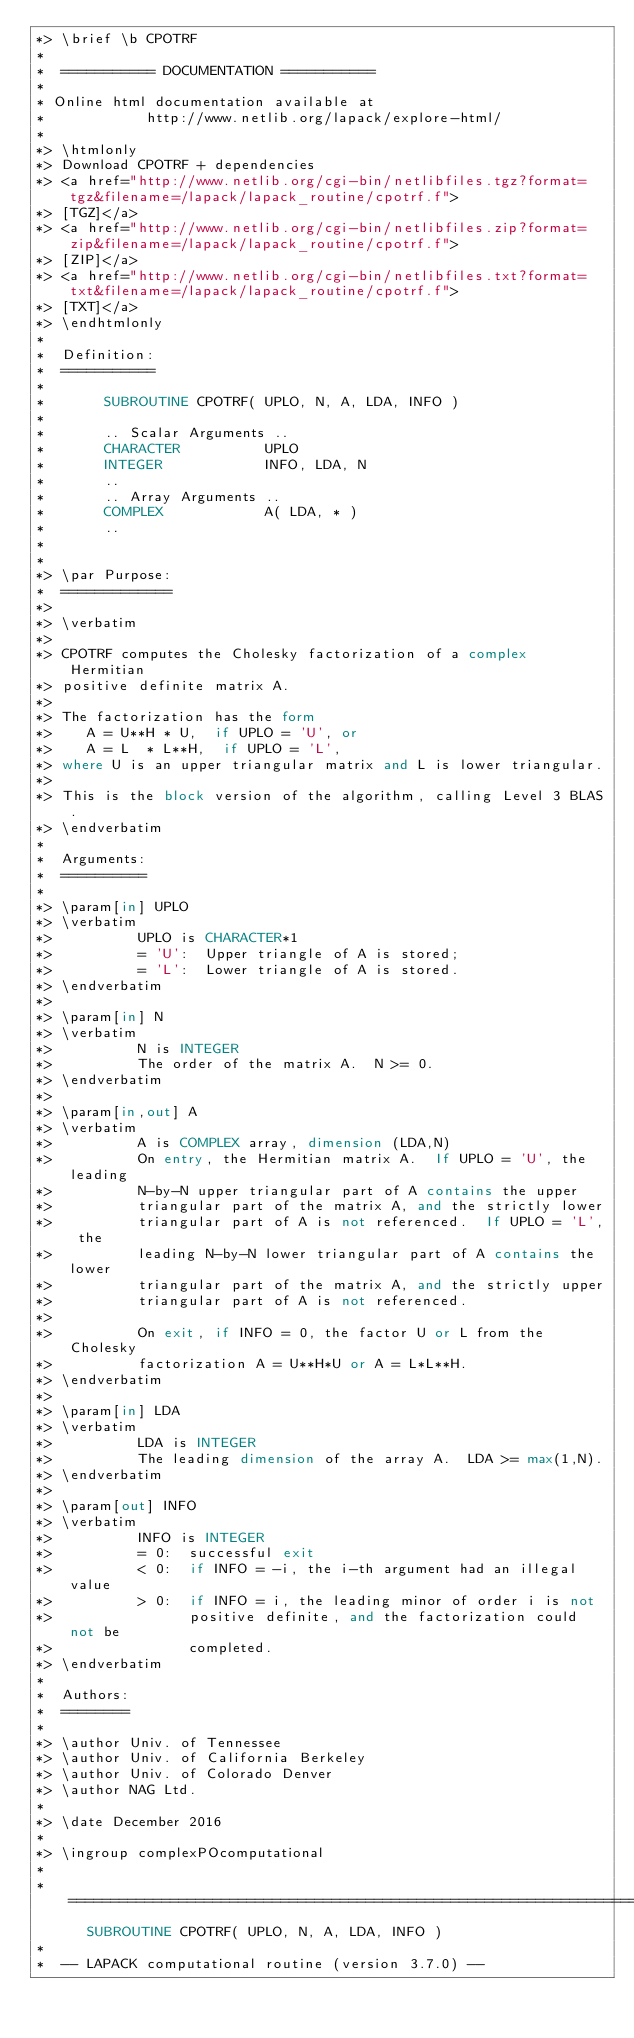<code> <loc_0><loc_0><loc_500><loc_500><_FORTRAN_>*> \brief \b CPOTRF
*
*  =========== DOCUMENTATION ===========
*
* Online html documentation available at
*            http://www.netlib.org/lapack/explore-html/
*
*> \htmlonly
*> Download CPOTRF + dependencies
*> <a href="http://www.netlib.org/cgi-bin/netlibfiles.tgz?format=tgz&filename=/lapack/lapack_routine/cpotrf.f">
*> [TGZ]</a>
*> <a href="http://www.netlib.org/cgi-bin/netlibfiles.zip?format=zip&filename=/lapack/lapack_routine/cpotrf.f">
*> [ZIP]</a>
*> <a href="http://www.netlib.org/cgi-bin/netlibfiles.txt?format=txt&filename=/lapack/lapack_routine/cpotrf.f">
*> [TXT]</a>
*> \endhtmlonly
*
*  Definition:
*  ===========
*
*       SUBROUTINE CPOTRF( UPLO, N, A, LDA, INFO )
*
*       .. Scalar Arguments ..
*       CHARACTER          UPLO
*       INTEGER            INFO, LDA, N
*       ..
*       .. Array Arguments ..
*       COMPLEX            A( LDA, * )
*       ..
*
*
*> \par Purpose:
*  =============
*>
*> \verbatim
*>
*> CPOTRF computes the Cholesky factorization of a complex Hermitian
*> positive definite matrix A.
*>
*> The factorization has the form
*>    A = U**H * U,  if UPLO = 'U', or
*>    A = L  * L**H,  if UPLO = 'L',
*> where U is an upper triangular matrix and L is lower triangular.
*>
*> This is the block version of the algorithm, calling Level 3 BLAS.
*> \endverbatim
*
*  Arguments:
*  ==========
*
*> \param[in] UPLO
*> \verbatim
*>          UPLO is CHARACTER*1
*>          = 'U':  Upper triangle of A is stored;
*>          = 'L':  Lower triangle of A is stored.
*> \endverbatim
*>
*> \param[in] N
*> \verbatim
*>          N is INTEGER
*>          The order of the matrix A.  N >= 0.
*> \endverbatim
*>
*> \param[in,out] A
*> \verbatim
*>          A is COMPLEX array, dimension (LDA,N)
*>          On entry, the Hermitian matrix A.  If UPLO = 'U', the leading
*>          N-by-N upper triangular part of A contains the upper
*>          triangular part of the matrix A, and the strictly lower
*>          triangular part of A is not referenced.  If UPLO = 'L', the
*>          leading N-by-N lower triangular part of A contains the lower
*>          triangular part of the matrix A, and the strictly upper
*>          triangular part of A is not referenced.
*>
*>          On exit, if INFO = 0, the factor U or L from the Cholesky
*>          factorization A = U**H*U or A = L*L**H.
*> \endverbatim
*>
*> \param[in] LDA
*> \verbatim
*>          LDA is INTEGER
*>          The leading dimension of the array A.  LDA >= max(1,N).
*> \endverbatim
*>
*> \param[out] INFO
*> \verbatim
*>          INFO is INTEGER
*>          = 0:  successful exit
*>          < 0:  if INFO = -i, the i-th argument had an illegal value
*>          > 0:  if INFO = i, the leading minor of order i is not
*>                positive definite, and the factorization could not be
*>                completed.
*> \endverbatim
*
*  Authors:
*  ========
*
*> \author Univ. of Tennessee
*> \author Univ. of California Berkeley
*> \author Univ. of Colorado Denver
*> \author NAG Ltd.
*
*> \date December 2016
*
*> \ingroup complexPOcomputational
*
*  =====================================================================
      SUBROUTINE CPOTRF( UPLO, N, A, LDA, INFO )
*
*  -- LAPACK computational routine (version 3.7.0) --</code> 